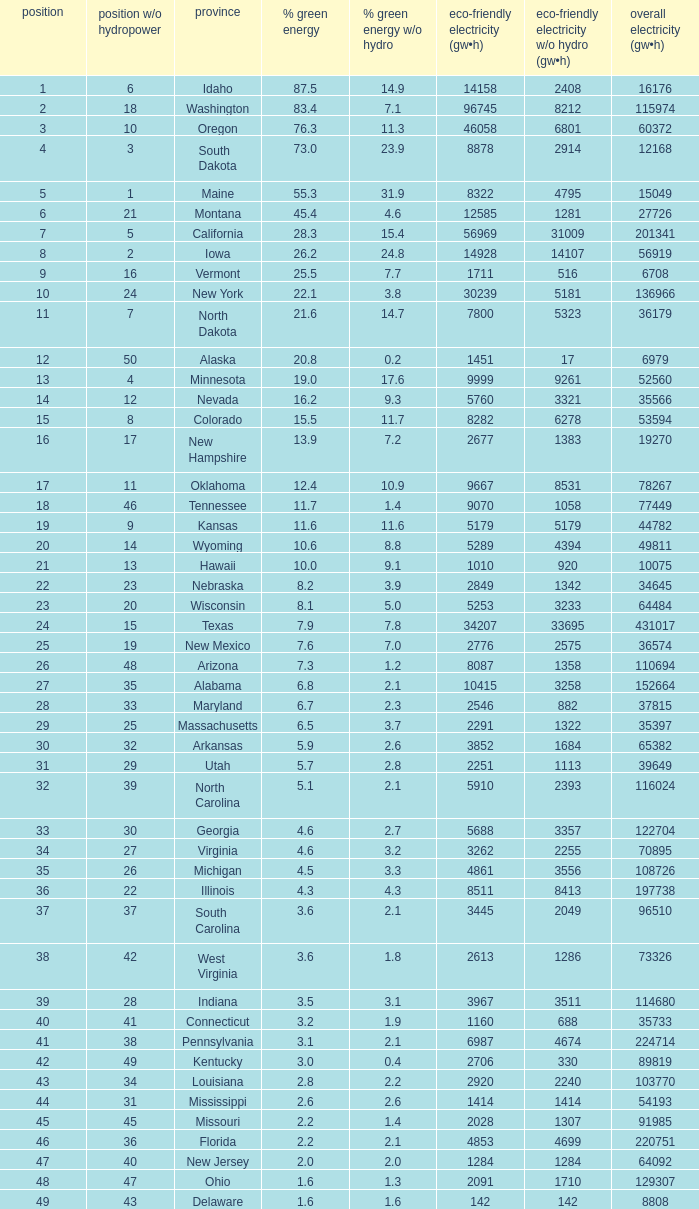Which state has 5179 (gw×h) of renewable energy without hydrogen power?wha Kansas. 